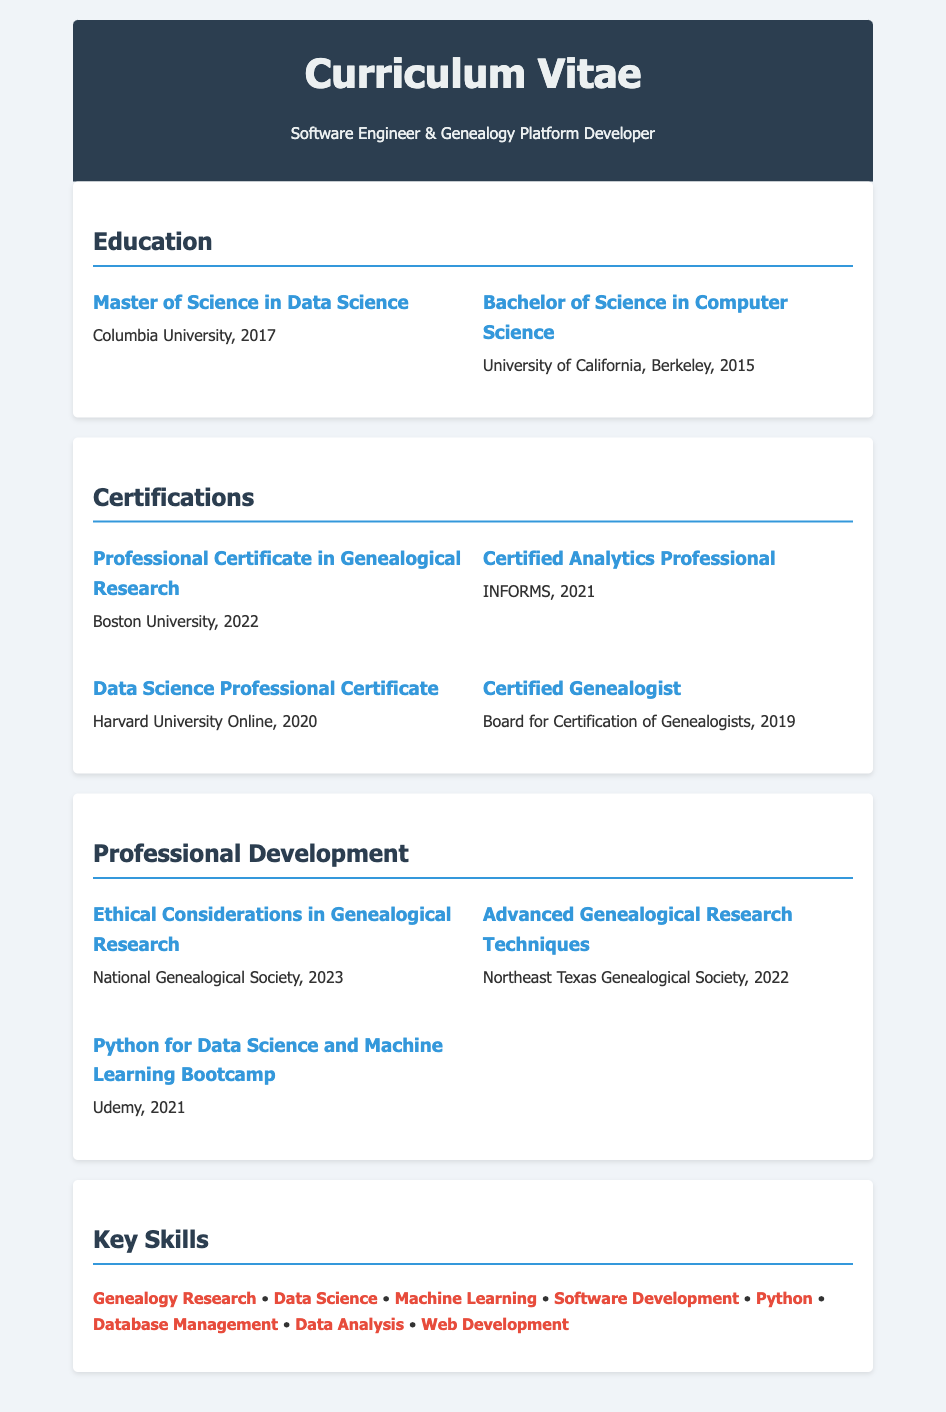What is the highest degree obtained? The document lists the degrees obtained, and the highest degree is the Master of Science in Data Science.
Answer: Master of Science in Data Science What year was the Bachelor of Science in Computer Science obtained? The document specifies the year of graduation for each degree, and the Bachelor of Science in Computer Science was obtained in 2015.
Answer: 2015 Which certification was obtained from Boston University? The document contains a list of certifications, and the one obtained from Boston University is the Professional Certificate in Genealogical Research.
Answer: Professional Certificate in Genealogical Research How many certifications are listed in the document? By counting the specific certifications mentioned in the document, a total of four certifications are listed.
Answer: 4 What is one of the key skills listed? The section on key skills provides various skills, and one example is Genealogy Research.
Answer: Genealogy Research Which organization issued the Certified Genealogist certification? The document mentions the certifying body for each certification, and the Certified Genealogist certification was issued by the Board for Certification of Genealogists.
Answer: Board for Certification of Genealogists What year was the Data Science Professional Certificate obtained? The document lists the year for each certification, and the Data Science Professional Certificate was obtained in 2020.
Answer: 2020 Which course was taken for professional development in 2023? The document includes titles of professional development courses, and one taken in 2023 is Ethical Considerations in Genealogical Research.
Answer: Ethical Considerations in Genealogical Research 